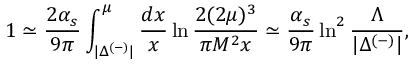Convert formula to latex. <formula><loc_0><loc_0><loc_500><loc_500>1 \simeq \frac { 2 \alpha _ { s } } { 9 \pi } \int _ { | \Delta ^ { ( - ) } | } ^ { \mu } \frac { d x } { x } \ln \frac { 2 ( 2 \mu ) ^ { 3 } } { \pi M ^ { 2 } x } \simeq \frac { \alpha _ { s } } { 9 \pi } \ln ^ { 2 } \frac { \Lambda } { | \Delta ^ { ( - ) } | } ,</formula> 